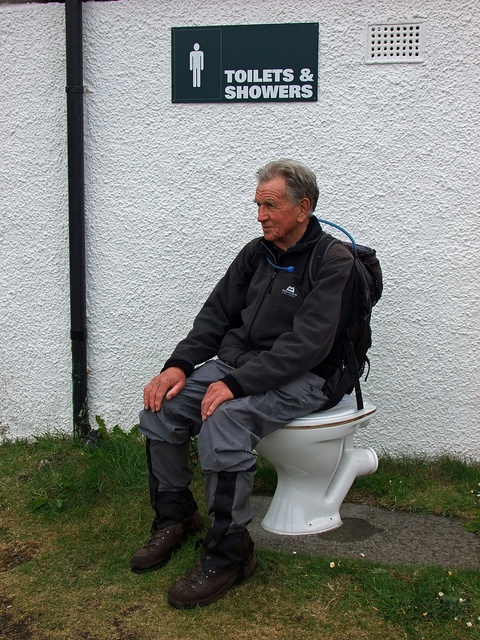Describe the objects in this image and their specific colors. I can see people in gray, black, brown, and maroon tones, toilet in gray, darkgray, and lightgray tones, and backpack in gray, black, and darkgray tones in this image. 